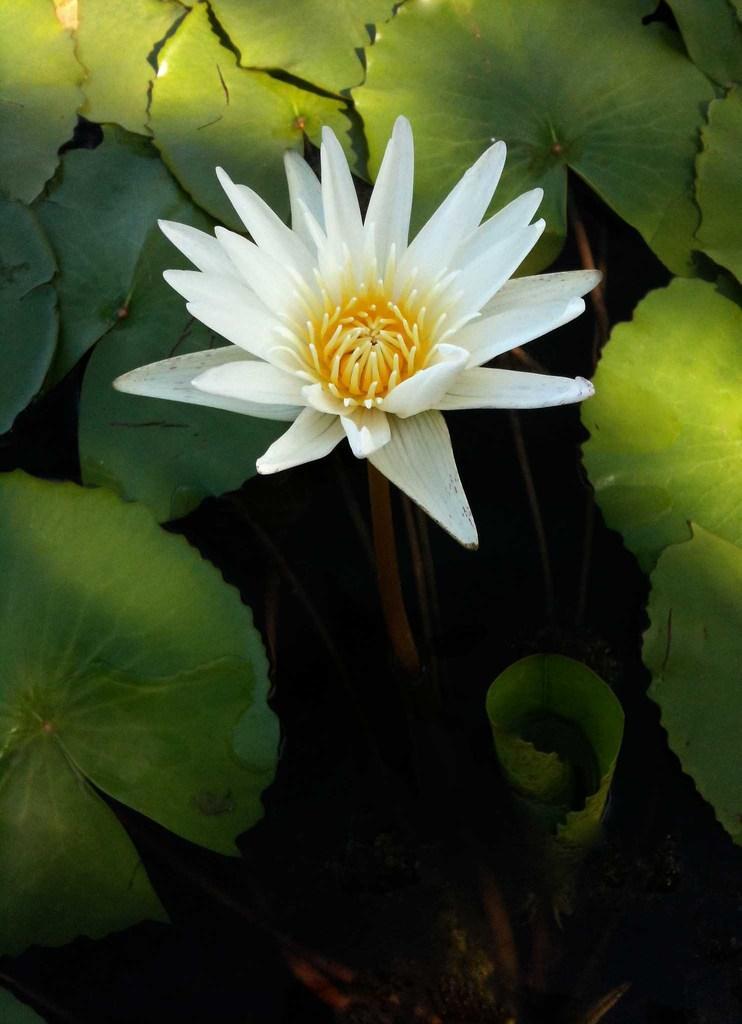In one or two sentences, can you explain what this image depicts? We can see colorful flower and green leaves. 